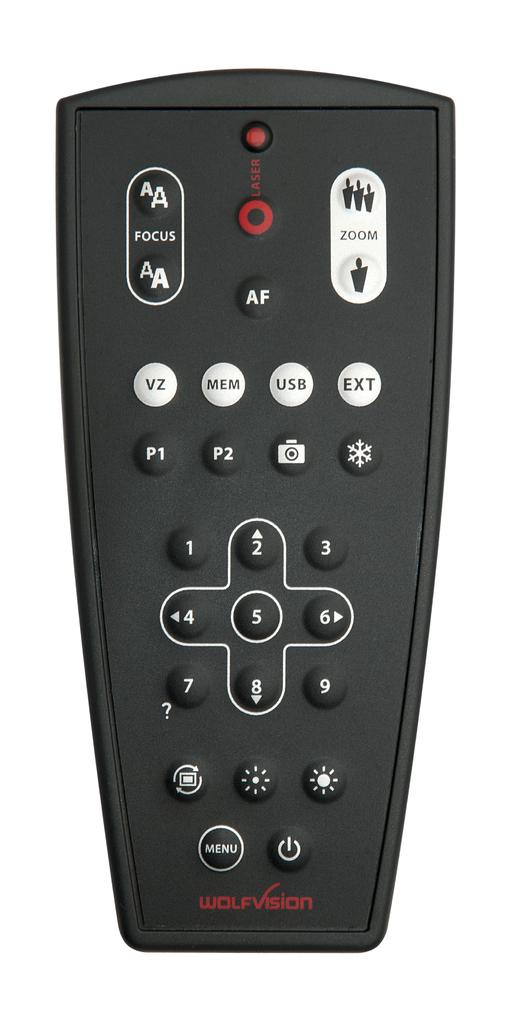Provide a one-sentence caption for the provided image. A Wolfvision black remote with a USB button as well. 